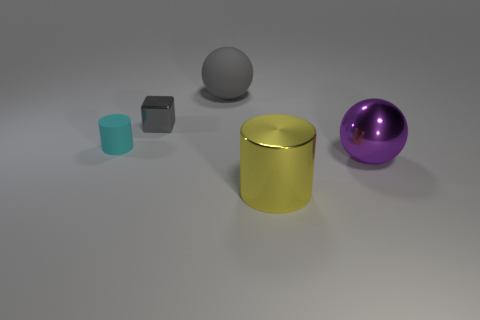What number of other things are the same size as the cyan matte thing?
Give a very brief answer. 1. How many other things are the same color as the rubber ball?
Your answer should be compact. 1. Are there any other things that are the same size as the cyan cylinder?
Keep it short and to the point. Yes. How many other objects are there of the same shape as the large gray rubber thing?
Keep it short and to the point. 1. Do the purple object and the matte cylinder have the same size?
Provide a short and direct response. No. Is there a gray matte sphere?
Provide a succinct answer. Yes. Is there any other thing that has the same material as the big cylinder?
Offer a very short reply. Yes. Are there any tiny cyan cylinders made of the same material as the purple object?
Give a very brief answer. No. There is a gray thing that is the same size as the cyan cylinder; what material is it?
Provide a short and direct response. Metal. What number of other large purple shiny objects have the same shape as the big purple object?
Give a very brief answer. 0. 